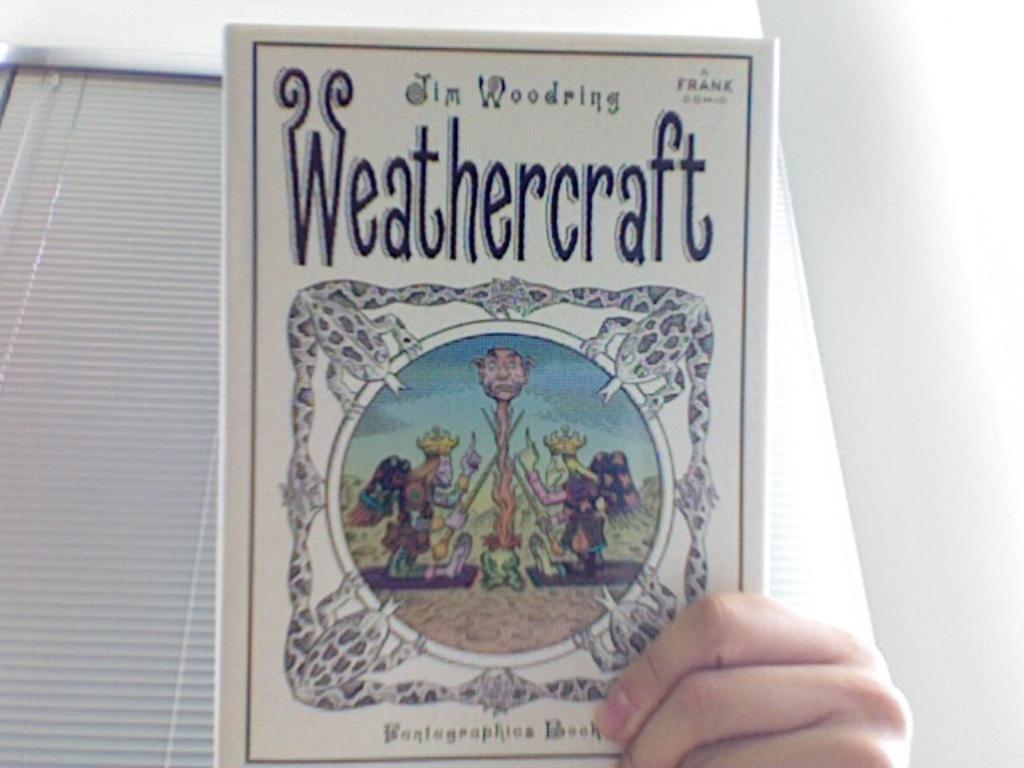What's the title of this book?
Provide a succinct answer. Weathercraft. Who published this book?
Ensure brevity in your answer.  Frank. 